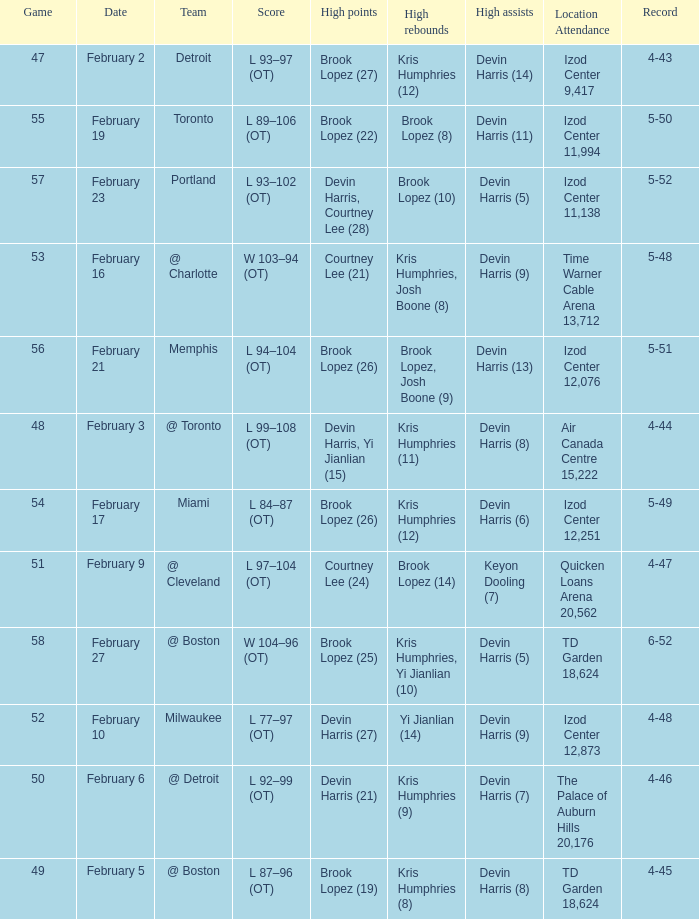What team was the game on February 27 played against? @ Boston. Can you give me this table as a dict? {'header': ['Game', 'Date', 'Team', 'Score', 'High points', 'High rebounds', 'High assists', 'Location Attendance', 'Record'], 'rows': [['47', 'February 2', 'Detroit', 'L 93–97 (OT)', 'Brook Lopez (27)', 'Kris Humphries (12)', 'Devin Harris (14)', 'Izod Center 9,417', '4-43'], ['55', 'February 19', 'Toronto', 'L 89–106 (OT)', 'Brook Lopez (22)', 'Brook Lopez (8)', 'Devin Harris (11)', 'Izod Center 11,994', '5-50'], ['57', 'February 23', 'Portland', 'L 93–102 (OT)', 'Devin Harris, Courtney Lee (28)', 'Brook Lopez (10)', 'Devin Harris (5)', 'Izod Center 11,138', '5-52'], ['53', 'February 16', '@ Charlotte', 'W 103–94 (OT)', 'Courtney Lee (21)', 'Kris Humphries, Josh Boone (8)', 'Devin Harris (9)', 'Time Warner Cable Arena 13,712', '5-48'], ['56', 'February 21', 'Memphis', 'L 94–104 (OT)', 'Brook Lopez (26)', 'Brook Lopez, Josh Boone (9)', 'Devin Harris (13)', 'Izod Center 12,076', '5-51'], ['48', 'February 3', '@ Toronto', 'L 99–108 (OT)', 'Devin Harris, Yi Jianlian (15)', 'Kris Humphries (11)', 'Devin Harris (8)', 'Air Canada Centre 15,222', '4-44'], ['54', 'February 17', 'Miami', 'L 84–87 (OT)', 'Brook Lopez (26)', 'Kris Humphries (12)', 'Devin Harris (6)', 'Izod Center 12,251', '5-49'], ['51', 'February 9', '@ Cleveland', 'L 97–104 (OT)', 'Courtney Lee (24)', 'Brook Lopez (14)', 'Keyon Dooling (7)', 'Quicken Loans Arena 20,562', '4-47'], ['58', 'February 27', '@ Boston', 'W 104–96 (OT)', 'Brook Lopez (25)', 'Kris Humphries, Yi Jianlian (10)', 'Devin Harris (5)', 'TD Garden 18,624', '6-52'], ['52', 'February 10', 'Milwaukee', 'L 77–97 (OT)', 'Devin Harris (27)', 'Yi Jianlian (14)', 'Devin Harris (9)', 'Izod Center 12,873', '4-48'], ['50', 'February 6', '@ Detroit', 'L 92–99 (OT)', 'Devin Harris (21)', 'Kris Humphries (9)', 'Devin Harris (7)', 'The Palace of Auburn Hills 20,176', '4-46'], ['49', 'February 5', '@ Boston', 'L 87–96 (OT)', 'Brook Lopez (19)', 'Kris Humphries (8)', 'Devin Harris (8)', 'TD Garden 18,624', '4-45']]} 